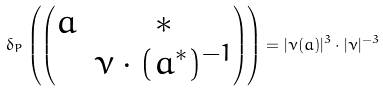Convert formula to latex. <formula><loc_0><loc_0><loc_500><loc_500>\delta _ { P } \left ( \begin{pmatrix} a & * \\ & \nu \cdot ( a ^ { * } ) ^ { - 1 } \end{pmatrix} \right ) = | \nu ( a ) | ^ { 3 } \cdot | \nu | ^ { - 3 }</formula> 